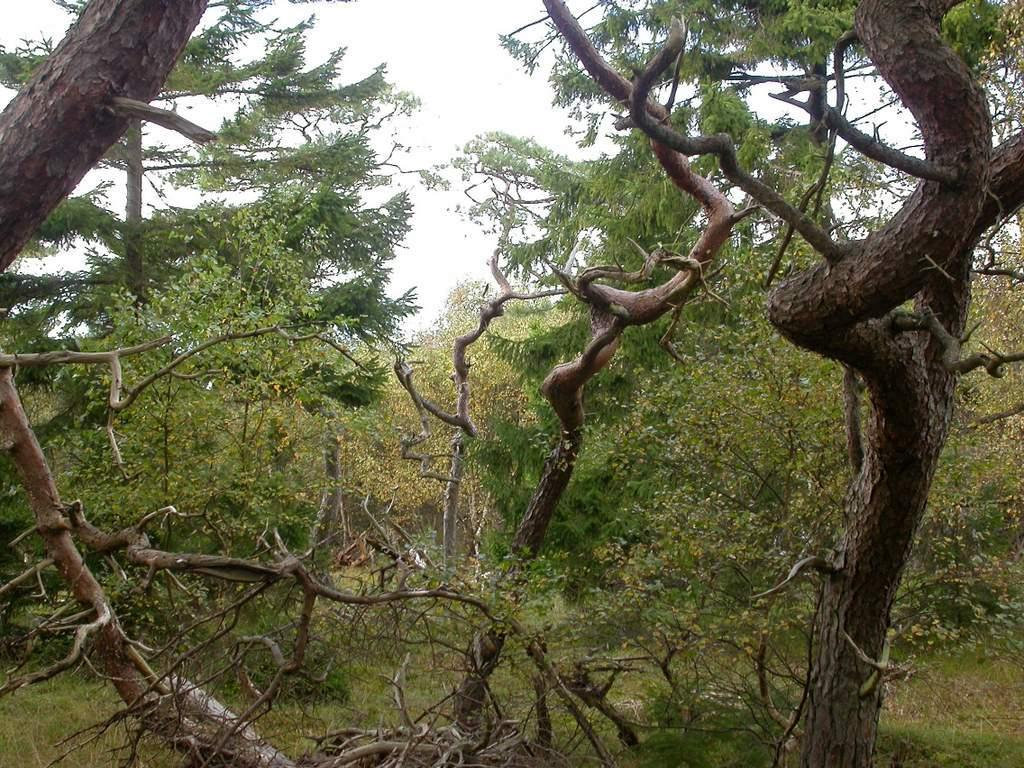What type of vegetation can be seen in the image? There are trees in the image. What is the color of the trees in the image? The trees are green in color. What else is visible in the image besides the trees? The sky is visible in the image. What is the color of the sky in the image? The sky is white in color. What position does the calendar hold in the image? There is no calendar present in the image. What type of head is visible in the image? There is no head visible in the image. 